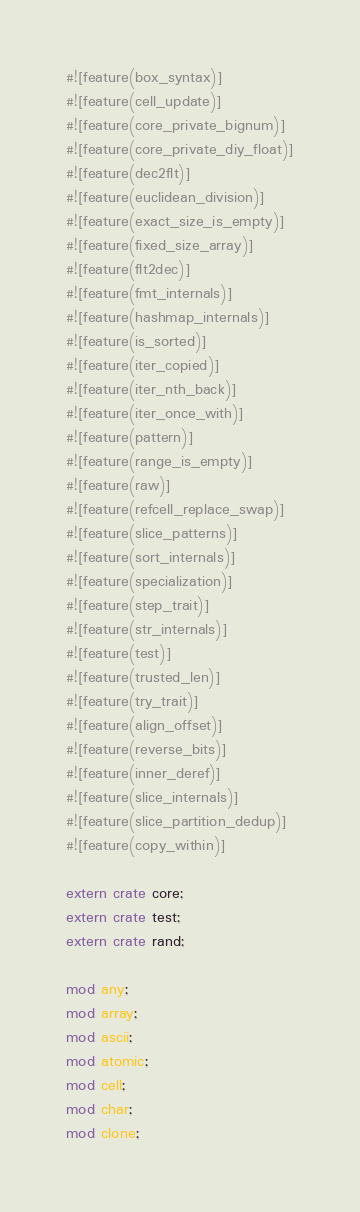Convert code to text. <code><loc_0><loc_0><loc_500><loc_500><_Rust_>#![feature(box_syntax)]
#![feature(cell_update)]
#![feature(core_private_bignum)]
#![feature(core_private_diy_float)]
#![feature(dec2flt)]
#![feature(euclidean_division)]
#![feature(exact_size_is_empty)]
#![feature(fixed_size_array)]
#![feature(flt2dec)]
#![feature(fmt_internals)]
#![feature(hashmap_internals)]
#![feature(is_sorted)]
#![feature(iter_copied)]
#![feature(iter_nth_back)]
#![feature(iter_once_with)]
#![feature(pattern)]
#![feature(range_is_empty)]
#![feature(raw)]
#![feature(refcell_replace_swap)]
#![feature(slice_patterns)]
#![feature(sort_internals)]
#![feature(specialization)]
#![feature(step_trait)]
#![feature(str_internals)]
#![feature(test)]
#![feature(trusted_len)]
#![feature(try_trait)]
#![feature(align_offset)]
#![feature(reverse_bits)]
#![feature(inner_deref)]
#![feature(slice_internals)]
#![feature(slice_partition_dedup)]
#![feature(copy_within)]

extern crate core;
extern crate test;
extern crate rand;

mod any;
mod array;
mod ascii;
mod atomic;
mod cell;
mod char;
mod clone;</code> 